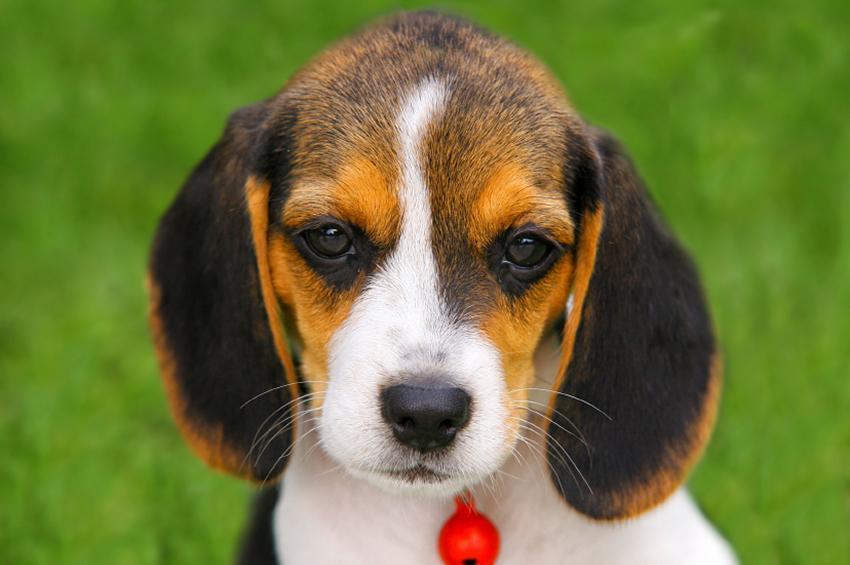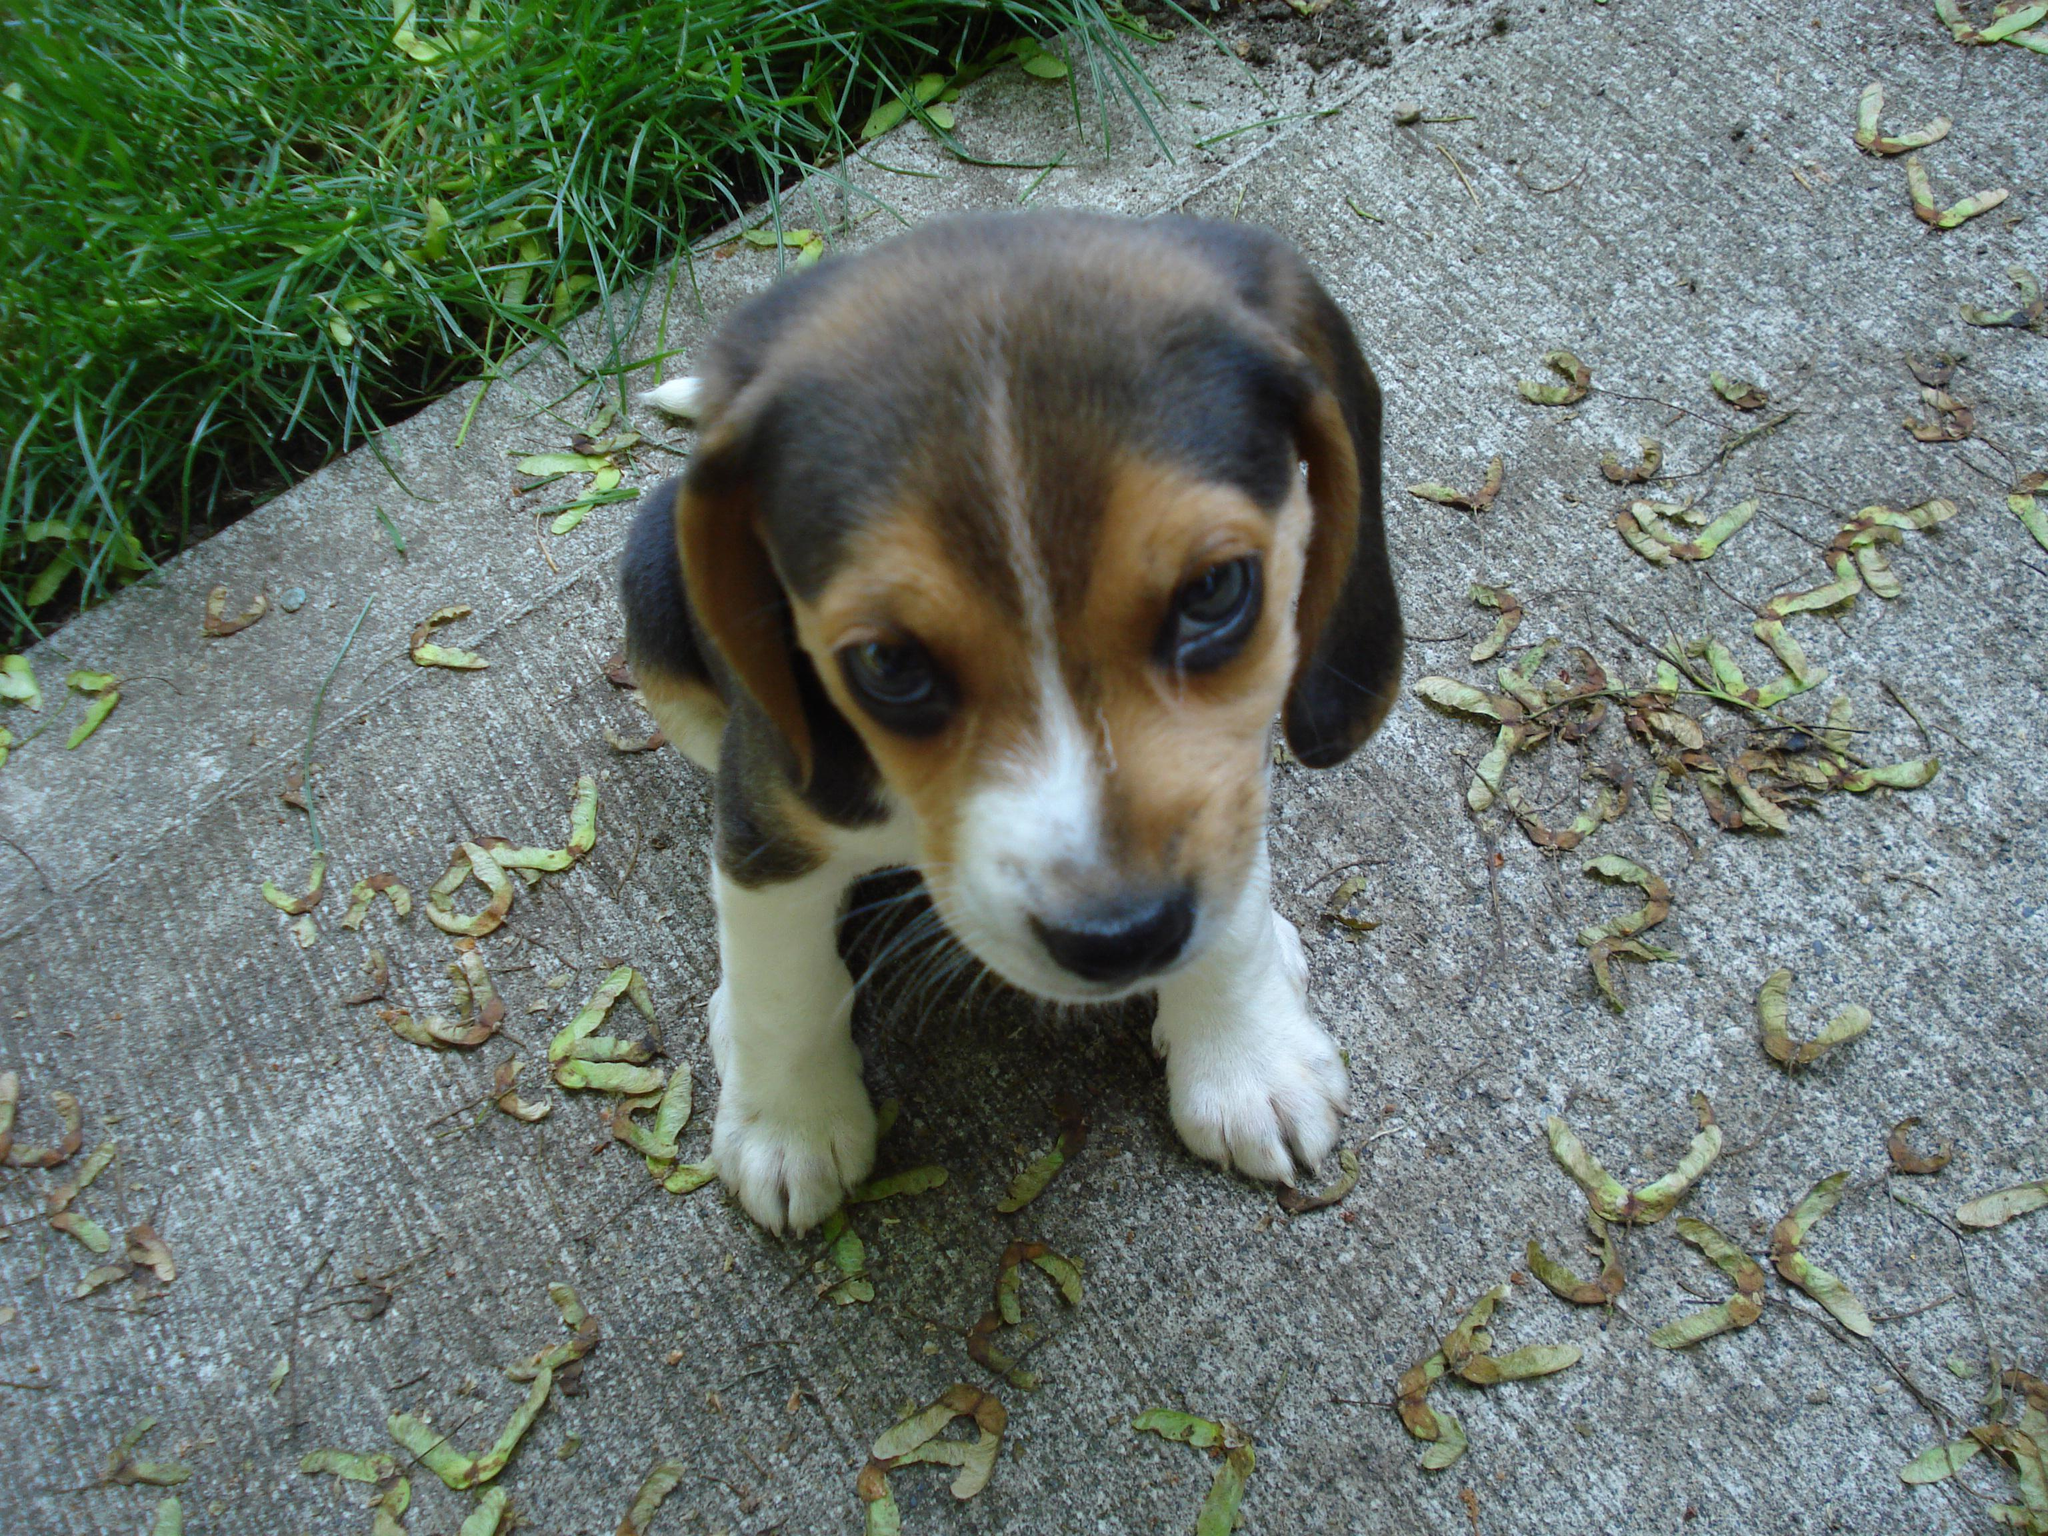The first image is the image on the left, the second image is the image on the right. Considering the images on both sides, is "Each image contains one dog, and one image shows a sitting puppy while the other shows a tri-color beagle wearing something around its neck." valid? Answer yes or no. Yes. The first image is the image on the left, the second image is the image on the right. For the images shown, is this caption "Exactly one dog in the right image is standing." true? Answer yes or no. No. 